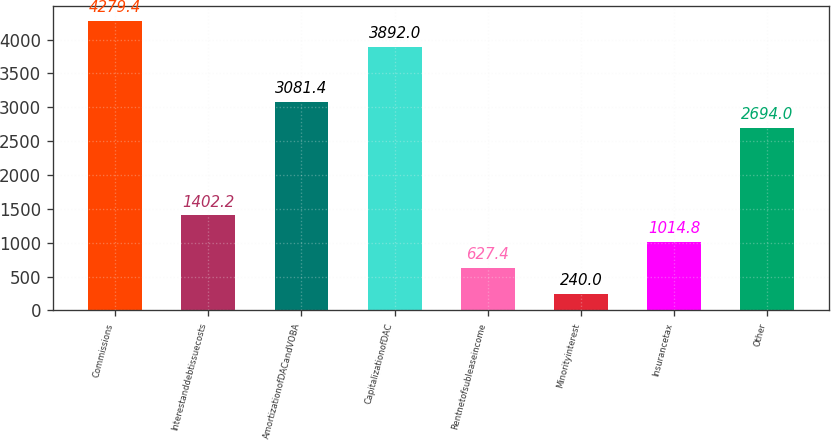Convert chart. <chart><loc_0><loc_0><loc_500><loc_500><bar_chart><fcel>Commissions<fcel>Interestanddebtissuecosts<fcel>AmortizationofDACandVOBA<fcel>CapitalizationofDAC<fcel>Rentnetofsubleaseincome<fcel>Minorityinterest<fcel>Insurancetax<fcel>Other<nl><fcel>4279.4<fcel>1402.2<fcel>3081.4<fcel>3892<fcel>627.4<fcel>240<fcel>1014.8<fcel>2694<nl></chart> 